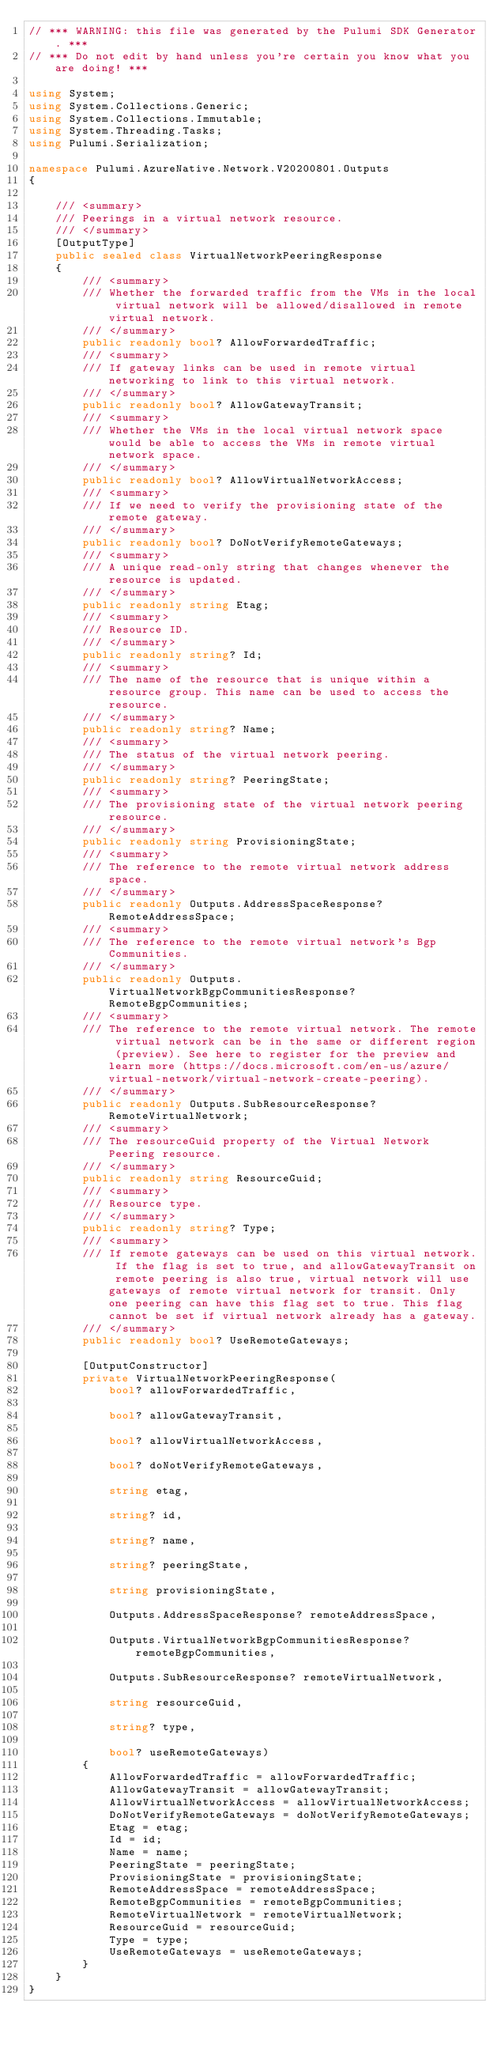Convert code to text. <code><loc_0><loc_0><loc_500><loc_500><_C#_>// *** WARNING: this file was generated by the Pulumi SDK Generator. ***
// *** Do not edit by hand unless you're certain you know what you are doing! ***

using System;
using System.Collections.Generic;
using System.Collections.Immutable;
using System.Threading.Tasks;
using Pulumi.Serialization;

namespace Pulumi.AzureNative.Network.V20200801.Outputs
{

    /// <summary>
    /// Peerings in a virtual network resource.
    /// </summary>
    [OutputType]
    public sealed class VirtualNetworkPeeringResponse
    {
        /// <summary>
        /// Whether the forwarded traffic from the VMs in the local virtual network will be allowed/disallowed in remote virtual network.
        /// </summary>
        public readonly bool? AllowForwardedTraffic;
        /// <summary>
        /// If gateway links can be used in remote virtual networking to link to this virtual network.
        /// </summary>
        public readonly bool? AllowGatewayTransit;
        /// <summary>
        /// Whether the VMs in the local virtual network space would be able to access the VMs in remote virtual network space.
        /// </summary>
        public readonly bool? AllowVirtualNetworkAccess;
        /// <summary>
        /// If we need to verify the provisioning state of the remote gateway.
        /// </summary>
        public readonly bool? DoNotVerifyRemoteGateways;
        /// <summary>
        /// A unique read-only string that changes whenever the resource is updated.
        /// </summary>
        public readonly string Etag;
        /// <summary>
        /// Resource ID.
        /// </summary>
        public readonly string? Id;
        /// <summary>
        /// The name of the resource that is unique within a resource group. This name can be used to access the resource.
        /// </summary>
        public readonly string? Name;
        /// <summary>
        /// The status of the virtual network peering.
        /// </summary>
        public readonly string? PeeringState;
        /// <summary>
        /// The provisioning state of the virtual network peering resource.
        /// </summary>
        public readonly string ProvisioningState;
        /// <summary>
        /// The reference to the remote virtual network address space.
        /// </summary>
        public readonly Outputs.AddressSpaceResponse? RemoteAddressSpace;
        /// <summary>
        /// The reference to the remote virtual network's Bgp Communities.
        /// </summary>
        public readonly Outputs.VirtualNetworkBgpCommunitiesResponse? RemoteBgpCommunities;
        /// <summary>
        /// The reference to the remote virtual network. The remote virtual network can be in the same or different region (preview). See here to register for the preview and learn more (https://docs.microsoft.com/en-us/azure/virtual-network/virtual-network-create-peering).
        /// </summary>
        public readonly Outputs.SubResourceResponse? RemoteVirtualNetwork;
        /// <summary>
        /// The resourceGuid property of the Virtual Network Peering resource.
        /// </summary>
        public readonly string ResourceGuid;
        /// <summary>
        /// Resource type.
        /// </summary>
        public readonly string? Type;
        /// <summary>
        /// If remote gateways can be used on this virtual network. If the flag is set to true, and allowGatewayTransit on remote peering is also true, virtual network will use gateways of remote virtual network for transit. Only one peering can have this flag set to true. This flag cannot be set if virtual network already has a gateway.
        /// </summary>
        public readonly bool? UseRemoteGateways;

        [OutputConstructor]
        private VirtualNetworkPeeringResponse(
            bool? allowForwardedTraffic,

            bool? allowGatewayTransit,

            bool? allowVirtualNetworkAccess,

            bool? doNotVerifyRemoteGateways,

            string etag,

            string? id,

            string? name,

            string? peeringState,

            string provisioningState,

            Outputs.AddressSpaceResponse? remoteAddressSpace,

            Outputs.VirtualNetworkBgpCommunitiesResponse? remoteBgpCommunities,

            Outputs.SubResourceResponse? remoteVirtualNetwork,

            string resourceGuid,

            string? type,

            bool? useRemoteGateways)
        {
            AllowForwardedTraffic = allowForwardedTraffic;
            AllowGatewayTransit = allowGatewayTransit;
            AllowVirtualNetworkAccess = allowVirtualNetworkAccess;
            DoNotVerifyRemoteGateways = doNotVerifyRemoteGateways;
            Etag = etag;
            Id = id;
            Name = name;
            PeeringState = peeringState;
            ProvisioningState = provisioningState;
            RemoteAddressSpace = remoteAddressSpace;
            RemoteBgpCommunities = remoteBgpCommunities;
            RemoteVirtualNetwork = remoteVirtualNetwork;
            ResourceGuid = resourceGuid;
            Type = type;
            UseRemoteGateways = useRemoteGateways;
        }
    }
}
</code> 